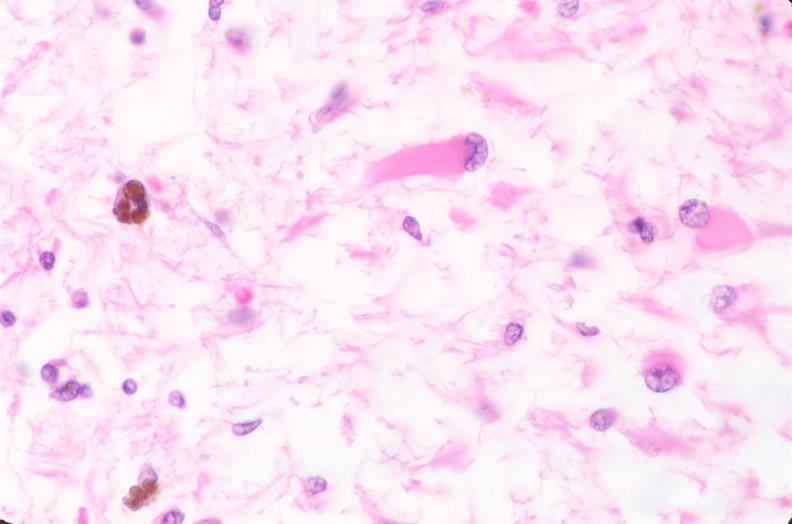where is this?
Answer the question using a single word or phrase. Nervous 